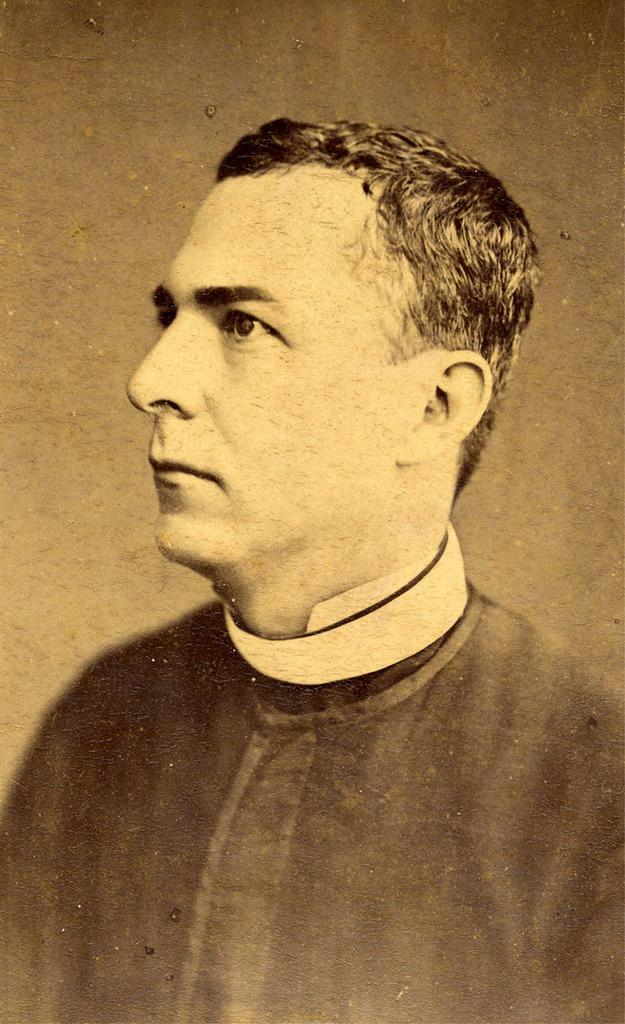What is featured in the image? There is a poster in the image. What is depicted on the poster? The poster contains a picture of a man. What can be observed about the man's appearance in the picture? The man in the picture is wearing clothes. What type of monkey can be seen climbing the church in the image? There is no monkey or church present in the image; it features a poster with a picture of a man wearing clothes. 